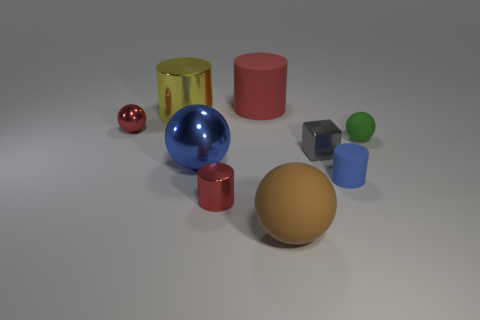What color is the tiny matte sphere that is on the right side of the large shiny thing behind the small red metal ball?
Make the answer very short. Green. How many objects are either small blue metal blocks or objects behind the cube?
Your answer should be very brief. 4. Is there a small shiny object of the same color as the tiny shiny ball?
Your answer should be very brief. Yes. How many yellow objects are either metal cylinders or tiny cubes?
Offer a very short reply. 1. How many other objects are there of the same size as the red rubber cylinder?
Offer a terse response. 3. How many large objects are either blue metallic things or gray matte cylinders?
Provide a succinct answer. 1. There is a block; is it the same size as the thing that is behind the large yellow metal object?
Give a very brief answer. No. What number of other things are the same shape as the gray metallic thing?
Offer a terse response. 0. What is the shape of the small blue object that is made of the same material as the brown sphere?
Make the answer very short. Cylinder. Are there any large gray metal objects?
Your response must be concise. No. 